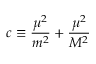<formula> <loc_0><loc_0><loc_500><loc_500>c \equiv \frac { \mu ^ { 2 } } { m ^ { 2 } } + \frac { \mu ^ { 2 } } { M ^ { 2 } }</formula> 